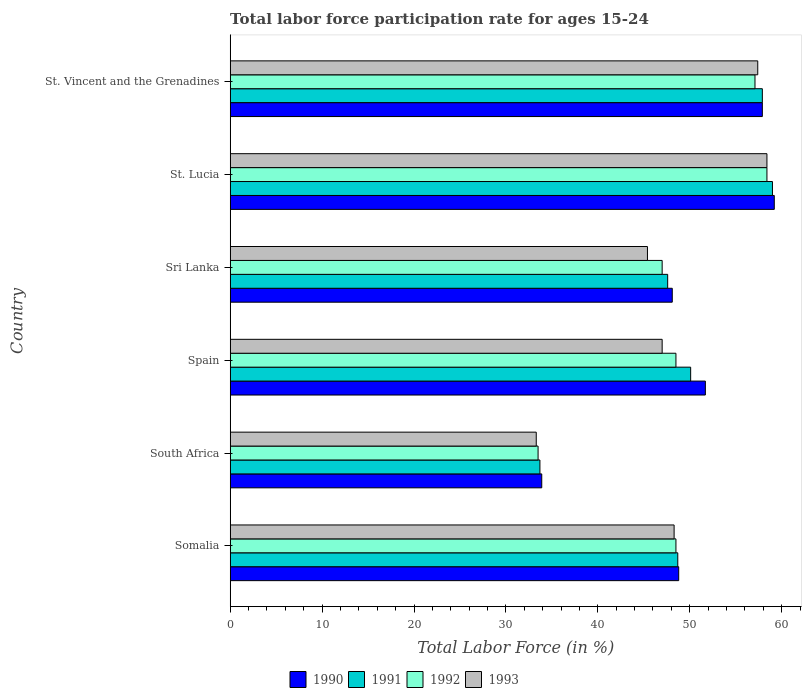How many different coloured bars are there?
Your response must be concise. 4. How many groups of bars are there?
Your answer should be compact. 6. Are the number of bars per tick equal to the number of legend labels?
Provide a short and direct response. Yes. How many bars are there on the 1st tick from the bottom?
Your answer should be very brief. 4. What is the label of the 5th group of bars from the top?
Offer a terse response. South Africa. In how many cases, is the number of bars for a given country not equal to the number of legend labels?
Give a very brief answer. 0. What is the labor force participation rate in 1993 in Sri Lanka?
Your answer should be compact. 45.4. Across all countries, what is the maximum labor force participation rate in 1993?
Give a very brief answer. 58.4. Across all countries, what is the minimum labor force participation rate in 1993?
Keep it short and to the point. 33.3. In which country was the labor force participation rate in 1991 maximum?
Keep it short and to the point. St. Lucia. In which country was the labor force participation rate in 1991 minimum?
Your answer should be compact. South Africa. What is the total labor force participation rate in 1992 in the graph?
Offer a very short reply. 293. What is the difference between the labor force participation rate in 1992 in Spain and that in Sri Lanka?
Provide a succinct answer. 1.5. What is the average labor force participation rate in 1992 per country?
Ensure brevity in your answer.  48.83. What is the difference between the labor force participation rate in 1991 and labor force participation rate in 1993 in St. Vincent and the Grenadines?
Keep it short and to the point. 0.5. What is the ratio of the labor force participation rate in 1991 in South Africa to that in St. Vincent and the Grenadines?
Ensure brevity in your answer.  0.58. Is the difference between the labor force participation rate in 1991 in Somalia and Sri Lanka greater than the difference between the labor force participation rate in 1993 in Somalia and Sri Lanka?
Your answer should be compact. No. What is the difference between the highest and the second highest labor force participation rate in 1992?
Offer a terse response. 1.3. What is the difference between the highest and the lowest labor force participation rate in 1990?
Provide a succinct answer. 25.3. Is it the case that in every country, the sum of the labor force participation rate in 1990 and labor force participation rate in 1991 is greater than the sum of labor force participation rate in 1993 and labor force participation rate in 1992?
Offer a terse response. No. What does the 2nd bar from the bottom in Somalia represents?
Keep it short and to the point. 1991. How many bars are there?
Make the answer very short. 24. Are all the bars in the graph horizontal?
Your answer should be compact. Yes. What is the difference between two consecutive major ticks on the X-axis?
Your answer should be very brief. 10. Does the graph contain any zero values?
Provide a succinct answer. No. How many legend labels are there?
Your response must be concise. 4. How are the legend labels stacked?
Provide a succinct answer. Horizontal. What is the title of the graph?
Provide a short and direct response. Total labor force participation rate for ages 15-24. What is the label or title of the Y-axis?
Make the answer very short. Country. What is the Total Labor Force (in %) in 1990 in Somalia?
Give a very brief answer. 48.8. What is the Total Labor Force (in %) in 1991 in Somalia?
Keep it short and to the point. 48.7. What is the Total Labor Force (in %) in 1992 in Somalia?
Your answer should be compact. 48.5. What is the Total Labor Force (in %) of 1993 in Somalia?
Give a very brief answer. 48.3. What is the Total Labor Force (in %) in 1990 in South Africa?
Offer a very short reply. 33.9. What is the Total Labor Force (in %) in 1991 in South Africa?
Provide a short and direct response. 33.7. What is the Total Labor Force (in %) of 1992 in South Africa?
Your response must be concise. 33.5. What is the Total Labor Force (in %) in 1993 in South Africa?
Your response must be concise. 33.3. What is the Total Labor Force (in %) in 1990 in Spain?
Make the answer very short. 51.7. What is the Total Labor Force (in %) in 1991 in Spain?
Offer a very short reply. 50.1. What is the Total Labor Force (in %) of 1992 in Spain?
Make the answer very short. 48.5. What is the Total Labor Force (in %) of 1990 in Sri Lanka?
Provide a succinct answer. 48.1. What is the Total Labor Force (in %) of 1991 in Sri Lanka?
Make the answer very short. 47.6. What is the Total Labor Force (in %) in 1993 in Sri Lanka?
Your response must be concise. 45.4. What is the Total Labor Force (in %) in 1990 in St. Lucia?
Provide a short and direct response. 59.2. What is the Total Labor Force (in %) of 1991 in St. Lucia?
Provide a succinct answer. 59. What is the Total Labor Force (in %) in 1992 in St. Lucia?
Give a very brief answer. 58.4. What is the Total Labor Force (in %) in 1993 in St. Lucia?
Offer a very short reply. 58.4. What is the Total Labor Force (in %) of 1990 in St. Vincent and the Grenadines?
Ensure brevity in your answer.  57.9. What is the Total Labor Force (in %) of 1991 in St. Vincent and the Grenadines?
Keep it short and to the point. 57.9. What is the Total Labor Force (in %) of 1992 in St. Vincent and the Grenadines?
Offer a very short reply. 57.1. What is the Total Labor Force (in %) of 1993 in St. Vincent and the Grenadines?
Your answer should be very brief. 57.4. Across all countries, what is the maximum Total Labor Force (in %) of 1990?
Your answer should be compact. 59.2. Across all countries, what is the maximum Total Labor Force (in %) in 1991?
Your answer should be compact. 59. Across all countries, what is the maximum Total Labor Force (in %) in 1992?
Provide a short and direct response. 58.4. Across all countries, what is the maximum Total Labor Force (in %) of 1993?
Offer a very short reply. 58.4. Across all countries, what is the minimum Total Labor Force (in %) in 1990?
Offer a terse response. 33.9. Across all countries, what is the minimum Total Labor Force (in %) of 1991?
Provide a short and direct response. 33.7. Across all countries, what is the minimum Total Labor Force (in %) of 1992?
Make the answer very short. 33.5. Across all countries, what is the minimum Total Labor Force (in %) in 1993?
Offer a very short reply. 33.3. What is the total Total Labor Force (in %) of 1990 in the graph?
Keep it short and to the point. 299.6. What is the total Total Labor Force (in %) in 1991 in the graph?
Your answer should be very brief. 297. What is the total Total Labor Force (in %) of 1992 in the graph?
Provide a short and direct response. 293. What is the total Total Labor Force (in %) in 1993 in the graph?
Keep it short and to the point. 289.8. What is the difference between the Total Labor Force (in %) in 1991 in Somalia and that in South Africa?
Keep it short and to the point. 15. What is the difference between the Total Labor Force (in %) in 1992 in Somalia and that in South Africa?
Ensure brevity in your answer.  15. What is the difference between the Total Labor Force (in %) of 1993 in Somalia and that in South Africa?
Offer a terse response. 15. What is the difference between the Total Labor Force (in %) of 1991 in Somalia and that in Spain?
Provide a succinct answer. -1.4. What is the difference between the Total Labor Force (in %) in 1992 in Somalia and that in Spain?
Provide a short and direct response. 0. What is the difference between the Total Labor Force (in %) of 1992 in Somalia and that in Sri Lanka?
Your answer should be compact. 1.5. What is the difference between the Total Labor Force (in %) in 1993 in Somalia and that in Sri Lanka?
Your answer should be very brief. 2.9. What is the difference between the Total Labor Force (in %) in 1991 in Somalia and that in St. Lucia?
Provide a succinct answer. -10.3. What is the difference between the Total Labor Force (in %) in 1992 in Somalia and that in St. Lucia?
Your response must be concise. -9.9. What is the difference between the Total Labor Force (in %) in 1993 in Somalia and that in St. Lucia?
Offer a terse response. -10.1. What is the difference between the Total Labor Force (in %) in 1991 in Somalia and that in St. Vincent and the Grenadines?
Keep it short and to the point. -9.2. What is the difference between the Total Labor Force (in %) in 1992 in Somalia and that in St. Vincent and the Grenadines?
Make the answer very short. -8.6. What is the difference between the Total Labor Force (in %) in 1993 in Somalia and that in St. Vincent and the Grenadines?
Offer a very short reply. -9.1. What is the difference between the Total Labor Force (in %) in 1990 in South Africa and that in Spain?
Your answer should be compact. -17.8. What is the difference between the Total Labor Force (in %) in 1991 in South Africa and that in Spain?
Offer a very short reply. -16.4. What is the difference between the Total Labor Force (in %) of 1992 in South Africa and that in Spain?
Provide a short and direct response. -15. What is the difference between the Total Labor Force (in %) in 1993 in South Africa and that in Spain?
Provide a short and direct response. -13.7. What is the difference between the Total Labor Force (in %) of 1991 in South Africa and that in Sri Lanka?
Offer a terse response. -13.9. What is the difference between the Total Labor Force (in %) of 1990 in South Africa and that in St. Lucia?
Keep it short and to the point. -25.3. What is the difference between the Total Labor Force (in %) of 1991 in South Africa and that in St. Lucia?
Give a very brief answer. -25.3. What is the difference between the Total Labor Force (in %) in 1992 in South Africa and that in St. Lucia?
Provide a short and direct response. -24.9. What is the difference between the Total Labor Force (in %) in 1993 in South Africa and that in St. Lucia?
Your response must be concise. -25.1. What is the difference between the Total Labor Force (in %) of 1991 in South Africa and that in St. Vincent and the Grenadines?
Ensure brevity in your answer.  -24.2. What is the difference between the Total Labor Force (in %) in 1992 in South Africa and that in St. Vincent and the Grenadines?
Keep it short and to the point. -23.6. What is the difference between the Total Labor Force (in %) of 1993 in South Africa and that in St. Vincent and the Grenadines?
Ensure brevity in your answer.  -24.1. What is the difference between the Total Labor Force (in %) of 1990 in Spain and that in Sri Lanka?
Your response must be concise. 3.6. What is the difference between the Total Labor Force (in %) of 1990 in Spain and that in St. Lucia?
Make the answer very short. -7.5. What is the difference between the Total Labor Force (in %) in 1991 in Spain and that in St. Lucia?
Make the answer very short. -8.9. What is the difference between the Total Labor Force (in %) in 1990 in Sri Lanka and that in St. Lucia?
Your answer should be very brief. -11.1. What is the difference between the Total Labor Force (in %) in 1991 in Sri Lanka and that in St. Lucia?
Give a very brief answer. -11.4. What is the difference between the Total Labor Force (in %) in 1993 in Sri Lanka and that in St. Lucia?
Your answer should be compact. -13. What is the difference between the Total Labor Force (in %) in 1992 in Sri Lanka and that in St. Vincent and the Grenadines?
Provide a succinct answer. -10.1. What is the difference between the Total Labor Force (in %) of 1990 in St. Lucia and that in St. Vincent and the Grenadines?
Offer a very short reply. 1.3. What is the difference between the Total Labor Force (in %) in 1991 in St. Lucia and that in St. Vincent and the Grenadines?
Offer a very short reply. 1.1. What is the difference between the Total Labor Force (in %) of 1992 in St. Lucia and that in St. Vincent and the Grenadines?
Your response must be concise. 1.3. What is the difference between the Total Labor Force (in %) in 1993 in St. Lucia and that in St. Vincent and the Grenadines?
Provide a succinct answer. 1. What is the difference between the Total Labor Force (in %) in 1990 in Somalia and the Total Labor Force (in %) in 1992 in South Africa?
Your answer should be compact. 15.3. What is the difference between the Total Labor Force (in %) of 1990 in Somalia and the Total Labor Force (in %) of 1993 in South Africa?
Keep it short and to the point. 15.5. What is the difference between the Total Labor Force (in %) of 1992 in Somalia and the Total Labor Force (in %) of 1993 in South Africa?
Your answer should be very brief. 15.2. What is the difference between the Total Labor Force (in %) of 1990 in Somalia and the Total Labor Force (in %) of 1992 in Spain?
Give a very brief answer. 0.3. What is the difference between the Total Labor Force (in %) in 1990 in Somalia and the Total Labor Force (in %) in 1993 in Spain?
Give a very brief answer. 1.8. What is the difference between the Total Labor Force (in %) in 1991 in Somalia and the Total Labor Force (in %) in 1992 in Spain?
Your answer should be compact. 0.2. What is the difference between the Total Labor Force (in %) in 1992 in Somalia and the Total Labor Force (in %) in 1993 in Spain?
Your answer should be compact. 1.5. What is the difference between the Total Labor Force (in %) of 1990 in Somalia and the Total Labor Force (in %) of 1992 in Sri Lanka?
Give a very brief answer. 1.8. What is the difference between the Total Labor Force (in %) in 1990 in Somalia and the Total Labor Force (in %) in 1993 in Sri Lanka?
Keep it short and to the point. 3.4. What is the difference between the Total Labor Force (in %) in 1991 in Somalia and the Total Labor Force (in %) in 1992 in Sri Lanka?
Make the answer very short. 1.7. What is the difference between the Total Labor Force (in %) in 1991 in Somalia and the Total Labor Force (in %) in 1993 in Sri Lanka?
Provide a short and direct response. 3.3. What is the difference between the Total Labor Force (in %) of 1990 in Somalia and the Total Labor Force (in %) of 1991 in St. Vincent and the Grenadines?
Ensure brevity in your answer.  -9.1. What is the difference between the Total Labor Force (in %) in 1990 in Somalia and the Total Labor Force (in %) in 1993 in St. Vincent and the Grenadines?
Your answer should be very brief. -8.6. What is the difference between the Total Labor Force (in %) in 1991 in Somalia and the Total Labor Force (in %) in 1993 in St. Vincent and the Grenadines?
Provide a succinct answer. -8.7. What is the difference between the Total Labor Force (in %) of 1992 in Somalia and the Total Labor Force (in %) of 1993 in St. Vincent and the Grenadines?
Your answer should be very brief. -8.9. What is the difference between the Total Labor Force (in %) in 1990 in South Africa and the Total Labor Force (in %) in 1991 in Spain?
Your answer should be compact. -16.2. What is the difference between the Total Labor Force (in %) in 1990 in South Africa and the Total Labor Force (in %) in 1992 in Spain?
Give a very brief answer. -14.6. What is the difference between the Total Labor Force (in %) of 1991 in South Africa and the Total Labor Force (in %) of 1992 in Spain?
Ensure brevity in your answer.  -14.8. What is the difference between the Total Labor Force (in %) of 1991 in South Africa and the Total Labor Force (in %) of 1993 in Spain?
Provide a succinct answer. -13.3. What is the difference between the Total Labor Force (in %) in 1992 in South Africa and the Total Labor Force (in %) in 1993 in Spain?
Your response must be concise. -13.5. What is the difference between the Total Labor Force (in %) in 1990 in South Africa and the Total Labor Force (in %) in 1991 in Sri Lanka?
Offer a terse response. -13.7. What is the difference between the Total Labor Force (in %) of 1990 in South Africa and the Total Labor Force (in %) of 1992 in Sri Lanka?
Offer a very short reply. -13.1. What is the difference between the Total Labor Force (in %) of 1992 in South Africa and the Total Labor Force (in %) of 1993 in Sri Lanka?
Your answer should be very brief. -11.9. What is the difference between the Total Labor Force (in %) in 1990 in South Africa and the Total Labor Force (in %) in 1991 in St. Lucia?
Offer a very short reply. -25.1. What is the difference between the Total Labor Force (in %) in 1990 in South Africa and the Total Labor Force (in %) in 1992 in St. Lucia?
Your response must be concise. -24.5. What is the difference between the Total Labor Force (in %) of 1990 in South Africa and the Total Labor Force (in %) of 1993 in St. Lucia?
Provide a short and direct response. -24.5. What is the difference between the Total Labor Force (in %) in 1991 in South Africa and the Total Labor Force (in %) in 1992 in St. Lucia?
Make the answer very short. -24.7. What is the difference between the Total Labor Force (in %) in 1991 in South Africa and the Total Labor Force (in %) in 1993 in St. Lucia?
Provide a succinct answer. -24.7. What is the difference between the Total Labor Force (in %) in 1992 in South Africa and the Total Labor Force (in %) in 1993 in St. Lucia?
Give a very brief answer. -24.9. What is the difference between the Total Labor Force (in %) in 1990 in South Africa and the Total Labor Force (in %) in 1992 in St. Vincent and the Grenadines?
Ensure brevity in your answer.  -23.2. What is the difference between the Total Labor Force (in %) of 1990 in South Africa and the Total Labor Force (in %) of 1993 in St. Vincent and the Grenadines?
Provide a succinct answer. -23.5. What is the difference between the Total Labor Force (in %) of 1991 in South Africa and the Total Labor Force (in %) of 1992 in St. Vincent and the Grenadines?
Your response must be concise. -23.4. What is the difference between the Total Labor Force (in %) in 1991 in South Africa and the Total Labor Force (in %) in 1993 in St. Vincent and the Grenadines?
Your answer should be compact. -23.7. What is the difference between the Total Labor Force (in %) of 1992 in South Africa and the Total Labor Force (in %) of 1993 in St. Vincent and the Grenadines?
Make the answer very short. -23.9. What is the difference between the Total Labor Force (in %) in 1990 in Spain and the Total Labor Force (in %) in 1991 in Sri Lanka?
Make the answer very short. 4.1. What is the difference between the Total Labor Force (in %) of 1991 in Spain and the Total Labor Force (in %) of 1993 in Sri Lanka?
Provide a short and direct response. 4.7. What is the difference between the Total Labor Force (in %) in 1990 in Spain and the Total Labor Force (in %) in 1993 in St. Lucia?
Your answer should be compact. -6.7. What is the difference between the Total Labor Force (in %) in 1991 in Spain and the Total Labor Force (in %) in 1993 in St. Lucia?
Make the answer very short. -8.3. What is the difference between the Total Labor Force (in %) in 1992 in Spain and the Total Labor Force (in %) in 1993 in St. Lucia?
Keep it short and to the point. -9.9. What is the difference between the Total Labor Force (in %) in 1990 in Spain and the Total Labor Force (in %) in 1991 in St. Vincent and the Grenadines?
Provide a succinct answer. -6.2. What is the difference between the Total Labor Force (in %) of 1991 in Spain and the Total Labor Force (in %) of 1992 in St. Vincent and the Grenadines?
Provide a succinct answer. -7. What is the difference between the Total Labor Force (in %) of 1992 in Spain and the Total Labor Force (in %) of 1993 in St. Vincent and the Grenadines?
Give a very brief answer. -8.9. What is the difference between the Total Labor Force (in %) of 1990 in Sri Lanka and the Total Labor Force (in %) of 1992 in St. Lucia?
Provide a short and direct response. -10.3. What is the difference between the Total Labor Force (in %) in 1990 in Sri Lanka and the Total Labor Force (in %) in 1993 in St. Lucia?
Make the answer very short. -10.3. What is the difference between the Total Labor Force (in %) in 1991 in Sri Lanka and the Total Labor Force (in %) in 1992 in St. Lucia?
Offer a terse response. -10.8. What is the difference between the Total Labor Force (in %) in 1990 in Sri Lanka and the Total Labor Force (in %) in 1992 in St. Vincent and the Grenadines?
Make the answer very short. -9. What is the difference between the Total Labor Force (in %) in 1990 in Sri Lanka and the Total Labor Force (in %) in 1993 in St. Vincent and the Grenadines?
Your response must be concise. -9.3. What is the difference between the Total Labor Force (in %) of 1991 in Sri Lanka and the Total Labor Force (in %) of 1993 in St. Vincent and the Grenadines?
Provide a short and direct response. -9.8. What is the difference between the Total Labor Force (in %) in 1990 in St. Lucia and the Total Labor Force (in %) in 1993 in St. Vincent and the Grenadines?
Keep it short and to the point. 1.8. What is the difference between the Total Labor Force (in %) in 1991 in St. Lucia and the Total Labor Force (in %) in 1992 in St. Vincent and the Grenadines?
Your answer should be compact. 1.9. What is the difference between the Total Labor Force (in %) in 1991 in St. Lucia and the Total Labor Force (in %) in 1993 in St. Vincent and the Grenadines?
Offer a terse response. 1.6. What is the average Total Labor Force (in %) of 1990 per country?
Offer a very short reply. 49.93. What is the average Total Labor Force (in %) in 1991 per country?
Your answer should be very brief. 49.5. What is the average Total Labor Force (in %) of 1992 per country?
Provide a succinct answer. 48.83. What is the average Total Labor Force (in %) in 1993 per country?
Keep it short and to the point. 48.3. What is the difference between the Total Labor Force (in %) of 1990 and Total Labor Force (in %) of 1991 in Somalia?
Ensure brevity in your answer.  0.1. What is the difference between the Total Labor Force (in %) in 1990 and Total Labor Force (in %) in 1992 in Somalia?
Your answer should be compact. 0.3. What is the difference between the Total Labor Force (in %) in 1991 and Total Labor Force (in %) in 1992 in Somalia?
Give a very brief answer. 0.2. What is the difference between the Total Labor Force (in %) of 1991 and Total Labor Force (in %) of 1993 in Somalia?
Offer a very short reply. 0.4. What is the difference between the Total Labor Force (in %) in 1990 and Total Labor Force (in %) in 1992 in South Africa?
Your response must be concise. 0.4. What is the difference between the Total Labor Force (in %) in 1990 and Total Labor Force (in %) in 1993 in South Africa?
Make the answer very short. 0.6. What is the difference between the Total Labor Force (in %) in 1992 and Total Labor Force (in %) in 1993 in South Africa?
Ensure brevity in your answer.  0.2. What is the difference between the Total Labor Force (in %) in 1990 and Total Labor Force (in %) in 1992 in Spain?
Keep it short and to the point. 3.2. What is the difference between the Total Labor Force (in %) in 1990 and Total Labor Force (in %) in 1993 in Spain?
Offer a terse response. 4.7. What is the difference between the Total Labor Force (in %) in 1991 and Total Labor Force (in %) in 1992 in Spain?
Ensure brevity in your answer.  1.6. What is the difference between the Total Labor Force (in %) of 1992 and Total Labor Force (in %) of 1993 in Spain?
Your answer should be compact. 1.5. What is the difference between the Total Labor Force (in %) in 1990 and Total Labor Force (in %) in 1991 in Sri Lanka?
Your answer should be compact. 0.5. What is the difference between the Total Labor Force (in %) of 1990 and Total Labor Force (in %) of 1993 in Sri Lanka?
Keep it short and to the point. 2.7. What is the difference between the Total Labor Force (in %) of 1992 and Total Labor Force (in %) of 1993 in Sri Lanka?
Offer a very short reply. 1.6. What is the difference between the Total Labor Force (in %) in 1990 and Total Labor Force (in %) in 1991 in St. Lucia?
Make the answer very short. 0.2. What is the difference between the Total Labor Force (in %) in 1990 and Total Labor Force (in %) in 1992 in St. Lucia?
Provide a succinct answer. 0.8. What is the difference between the Total Labor Force (in %) of 1990 and Total Labor Force (in %) of 1993 in St. Lucia?
Make the answer very short. 0.8. What is the difference between the Total Labor Force (in %) in 1990 and Total Labor Force (in %) in 1991 in St. Vincent and the Grenadines?
Ensure brevity in your answer.  0. What is the ratio of the Total Labor Force (in %) of 1990 in Somalia to that in South Africa?
Provide a succinct answer. 1.44. What is the ratio of the Total Labor Force (in %) in 1991 in Somalia to that in South Africa?
Provide a short and direct response. 1.45. What is the ratio of the Total Labor Force (in %) of 1992 in Somalia to that in South Africa?
Give a very brief answer. 1.45. What is the ratio of the Total Labor Force (in %) of 1993 in Somalia to that in South Africa?
Your answer should be compact. 1.45. What is the ratio of the Total Labor Force (in %) in 1990 in Somalia to that in Spain?
Your answer should be compact. 0.94. What is the ratio of the Total Labor Force (in %) of 1991 in Somalia to that in Spain?
Offer a terse response. 0.97. What is the ratio of the Total Labor Force (in %) in 1992 in Somalia to that in Spain?
Provide a short and direct response. 1. What is the ratio of the Total Labor Force (in %) in 1993 in Somalia to that in Spain?
Offer a very short reply. 1.03. What is the ratio of the Total Labor Force (in %) of 1990 in Somalia to that in Sri Lanka?
Provide a short and direct response. 1.01. What is the ratio of the Total Labor Force (in %) in 1991 in Somalia to that in Sri Lanka?
Your response must be concise. 1.02. What is the ratio of the Total Labor Force (in %) in 1992 in Somalia to that in Sri Lanka?
Make the answer very short. 1.03. What is the ratio of the Total Labor Force (in %) of 1993 in Somalia to that in Sri Lanka?
Make the answer very short. 1.06. What is the ratio of the Total Labor Force (in %) of 1990 in Somalia to that in St. Lucia?
Provide a short and direct response. 0.82. What is the ratio of the Total Labor Force (in %) in 1991 in Somalia to that in St. Lucia?
Your response must be concise. 0.83. What is the ratio of the Total Labor Force (in %) of 1992 in Somalia to that in St. Lucia?
Your answer should be compact. 0.83. What is the ratio of the Total Labor Force (in %) in 1993 in Somalia to that in St. Lucia?
Provide a succinct answer. 0.83. What is the ratio of the Total Labor Force (in %) of 1990 in Somalia to that in St. Vincent and the Grenadines?
Give a very brief answer. 0.84. What is the ratio of the Total Labor Force (in %) in 1991 in Somalia to that in St. Vincent and the Grenadines?
Offer a very short reply. 0.84. What is the ratio of the Total Labor Force (in %) in 1992 in Somalia to that in St. Vincent and the Grenadines?
Offer a terse response. 0.85. What is the ratio of the Total Labor Force (in %) of 1993 in Somalia to that in St. Vincent and the Grenadines?
Provide a succinct answer. 0.84. What is the ratio of the Total Labor Force (in %) of 1990 in South Africa to that in Spain?
Give a very brief answer. 0.66. What is the ratio of the Total Labor Force (in %) in 1991 in South Africa to that in Spain?
Your response must be concise. 0.67. What is the ratio of the Total Labor Force (in %) in 1992 in South Africa to that in Spain?
Offer a very short reply. 0.69. What is the ratio of the Total Labor Force (in %) in 1993 in South Africa to that in Spain?
Make the answer very short. 0.71. What is the ratio of the Total Labor Force (in %) of 1990 in South Africa to that in Sri Lanka?
Make the answer very short. 0.7. What is the ratio of the Total Labor Force (in %) in 1991 in South Africa to that in Sri Lanka?
Offer a terse response. 0.71. What is the ratio of the Total Labor Force (in %) in 1992 in South Africa to that in Sri Lanka?
Provide a succinct answer. 0.71. What is the ratio of the Total Labor Force (in %) in 1993 in South Africa to that in Sri Lanka?
Provide a short and direct response. 0.73. What is the ratio of the Total Labor Force (in %) in 1990 in South Africa to that in St. Lucia?
Your answer should be very brief. 0.57. What is the ratio of the Total Labor Force (in %) of 1991 in South Africa to that in St. Lucia?
Your answer should be compact. 0.57. What is the ratio of the Total Labor Force (in %) of 1992 in South Africa to that in St. Lucia?
Your answer should be compact. 0.57. What is the ratio of the Total Labor Force (in %) in 1993 in South Africa to that in St. Lucia?
Your response must be concise. 0.57. What is the ratio of the Total Labor Force (in %) of 1990 in South Africa to that in St. Vincent and the Grenadines?
Offer a terse response. 0.59. What is the ratio of the Total Labor Force (in %) of 1991 in South Africa to that in St. Vincent and the Grenadines?
Keep it short and to the point. 0.58. What is the ratio of the Total Labor Force (in %) in 1992 in South Africa to that in St. Vincent and the Grenadines?
Your answer should be compact. 0.59. What is the ratio of the Total Labor Force (in %) of 1993 in South Africa to that in St. Vincent and the Grenadines?
Give a very brief answer. 0.58. What is the ratio of the Total Labor Force (in %) of 1990 in Spain to that in Sri Lanka?
Make the answer very short. 1.07. What is the ratio of the Total Labor Force (in %) in 1991 in Spain to that in Sri Lanka?
Your response must be concise. 1.05. What is the ratio of the Total Labor Force (in %) in 1992 in Spain to that in Sri Lanka?
Your answer should be compact. 1.03. What is the ratio of the Total Labor Force (in %) in 1993 in Spain to that in Sri Lanka?
Keep it short and to the point. 1.04. What is the ratio of the Total Labor Force (in %) in 1990 in Spain to that in St. Lucia?
Your answer should be very brief. 0.87. What is the ratio of the Total Labor Force (in %) in 1991 in Spain to that in St. Lucia?
Your answer should be very brief. 0.85. What is the ratio of the Total Labor Force (in %) of 1992 in Spain to that in St. Lucia?
Ensure brevity in your answer.  0.83. What is the ratio of the Total Labor Force (in %) of 1993 in Spain to that in St. Lucia?
Offer a very short reply. 0.8. What is the ratio of the Total Labor Force (in %) in 1990 in Spain to that in St. Vincent and the Grenadines?
Provide a succinct answer. 0.89. What is the ratio of the Total Labor Force (in %) of 1991 in Spain to that in St. Vincent and the Grenadines?
Provide a short and direct response. 0.87. What is the ratio of the Total Labor Force (in %) in 1992 in Spain to that in St. Vincent and the Grenadines?
Your answer should be compact. 0.85. What is the ratio of the Total Labor Force (in %) of 1993 in Spain to that in St. Vincent and the Grenadines?
Offer a very short reply. 0.82. What is the ratio of the Total Labor Force (in %) in 1990 in Sri Lanka to that in St. Lucia?
Offer a terse response. 0.81. What is the ratio of the Total Labor Force (in %) of 1991 in Sri Lanka to that in St. Lucia?
Provide a succinct answer. 0.81. What is the ratio of the Total Labor Force (in %) of 1992 in Sri Lanka to that in St. Lucia?
Offer a terse response. 0.8. What is the ratio of the Total Labor Force (in %) in 1993 in Sri Lanka to that in St. Lucia?
Offer a terse response. 0.78. What is the ratio of the Total Labor Force (in %) in 1990 in Sri Lanka to that in St. Vincent and the Grenadines?
Offer a terse response. 0.83. What is the ratio of the Total Labor Force (in %) of 1991 in Sri Lanka to that in St. Vincent and the Grenadines?
Provide a short and direct response. 0.82. What is the ratio of the Total Labor Force (in %) in 1992 in Sri Lanka to that in St. Vincent and the Grenadines?
Ensure brevity in your answer.  0.82. What is the ratio of the Total Labor Force (in %) in 1993 in Sri Lanka to that in St. Vincent and the Grenadines?
Ensure brevity in your answer.  0.79. What is the ratio of the Total Labor Force (in %) in 1990 in St. Lucia to that in St. Vincent and the Grenadines?
Provide a succinct answer. 1.02. What is the ratio of the Total Labor Force (in %) of 1991 in St. Lucia to that in St. Vincent and the Grenadines?
Make the answer very short. 1.02. What is the ratio of the Total Labor Force (in %) of 1992 in St. Lucia to that in St. Vincent and the Grenadines?
Provide a short and direct response. 1.02. What is the ratio of the Total Labor Force (in %) in 1993 in St. Lucia to that in St. Vincent and the Grenadines?
Provide a succinct answer. 1.02. What is the difference between the highest and the second highest Total Labor Force (in %) of 1992?
Ensure brevity in your answer.  1.3. What is the difference between the highest and the second highest Total Labor Force (in %) in 1993?
Offer a terse response. 1. What is the difference between the highest and the lowest Total Labor Force (in %) in 1990?
Make the answer very short. 25.3. What is the difference between the highest and the lowest Total Labor Force (in %) in 1991?
Your response must be concise. 25.3. What is the difference between the highest and the lowest Total Labor Force (in %) in 1992?
Provide a short and direct response. 24.9. What is the difference between the highest and the lowest Total Labor Force (in %) in 1993?
Provide a succinct answer. 25.1. 